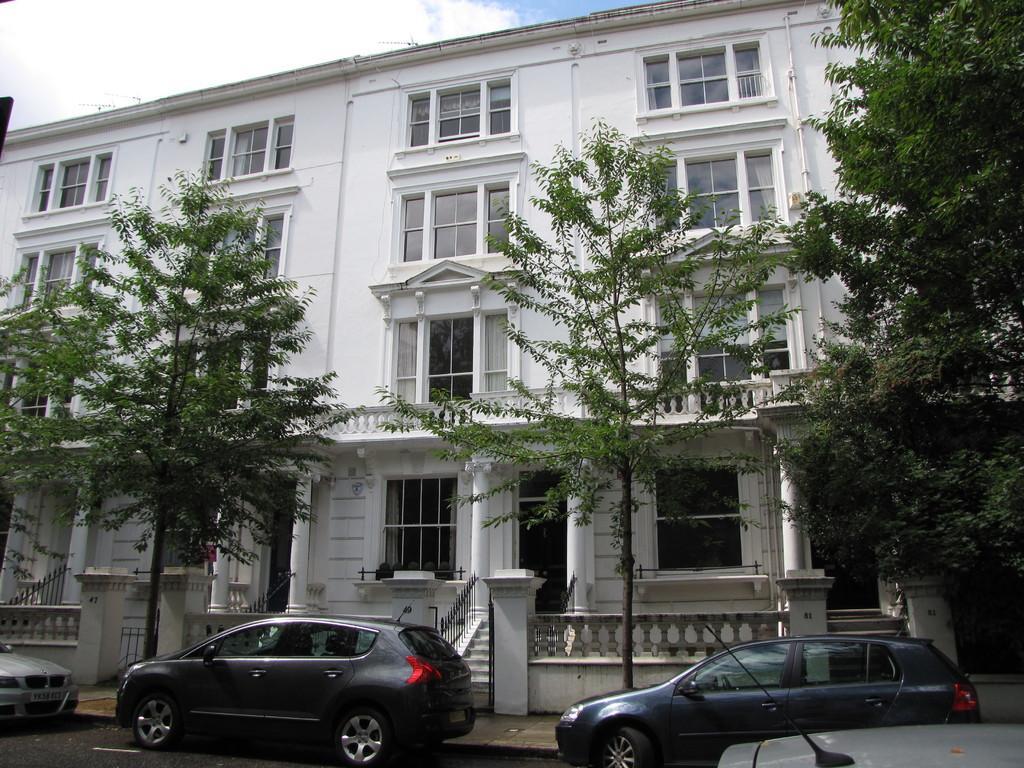Please provide a concise description of this image. In this image there are vehicles on the road, there are trees, a building, and in the background there is sky. 